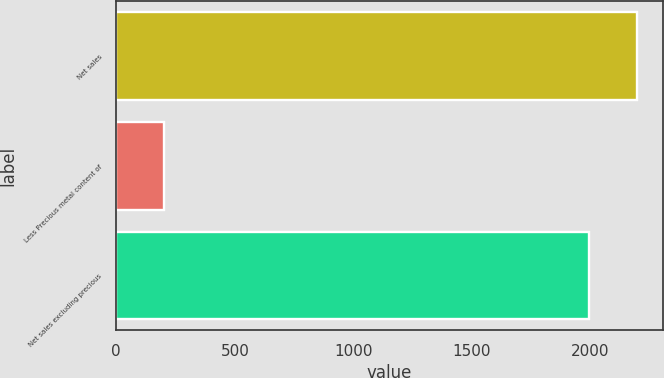Convert chart. <chart><loc_0><loc_0><loc_500><loc_500><bar_chart><fcel>Net sales<fcel>Less Precious metal content of<fcel>Net sales excluding precious<nl><fcel>2193.7<fcel>199.9<fcel>1993.8<nl></chart> 